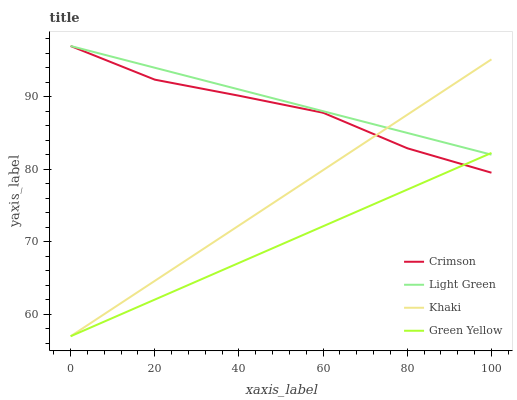Does Green Yellow have the minimum area under the curve?
Answer yes or no. Yes. Does Light Green have the maximum area under the curve?
Answer yes or no. Yes. Does Khaki have the minimum area under the curve?
Answer yes or no. No. Does Khaki have the maximum area under the curve?
Answer yes or no. No. Is Khaki the smoothest?
Answer yes or no. Yes. Is Crimson the roughest?
Answer yes or no. Yes. Is Green Yellow the smoothest?
Answer yes or no. No. Is Green Yellow the roughest?
Answer yes or no. No. Does Green Yellow have the lowest value?
Answer yes or no. Yes. Does Light Green have the lowest value?
Answer yes or no. No. Does Light Green have the highest value?
Answer yes or no. Yes. Does Khaki have the highest value?
Answer yes or no. No. Does Light Green intersect Crimson?
Answer yes or no. Yes. Is Light Green less than Crimson?
Answer yes or no. No. Is Light Green greater than Crimson?
Answer yes or no. No. 